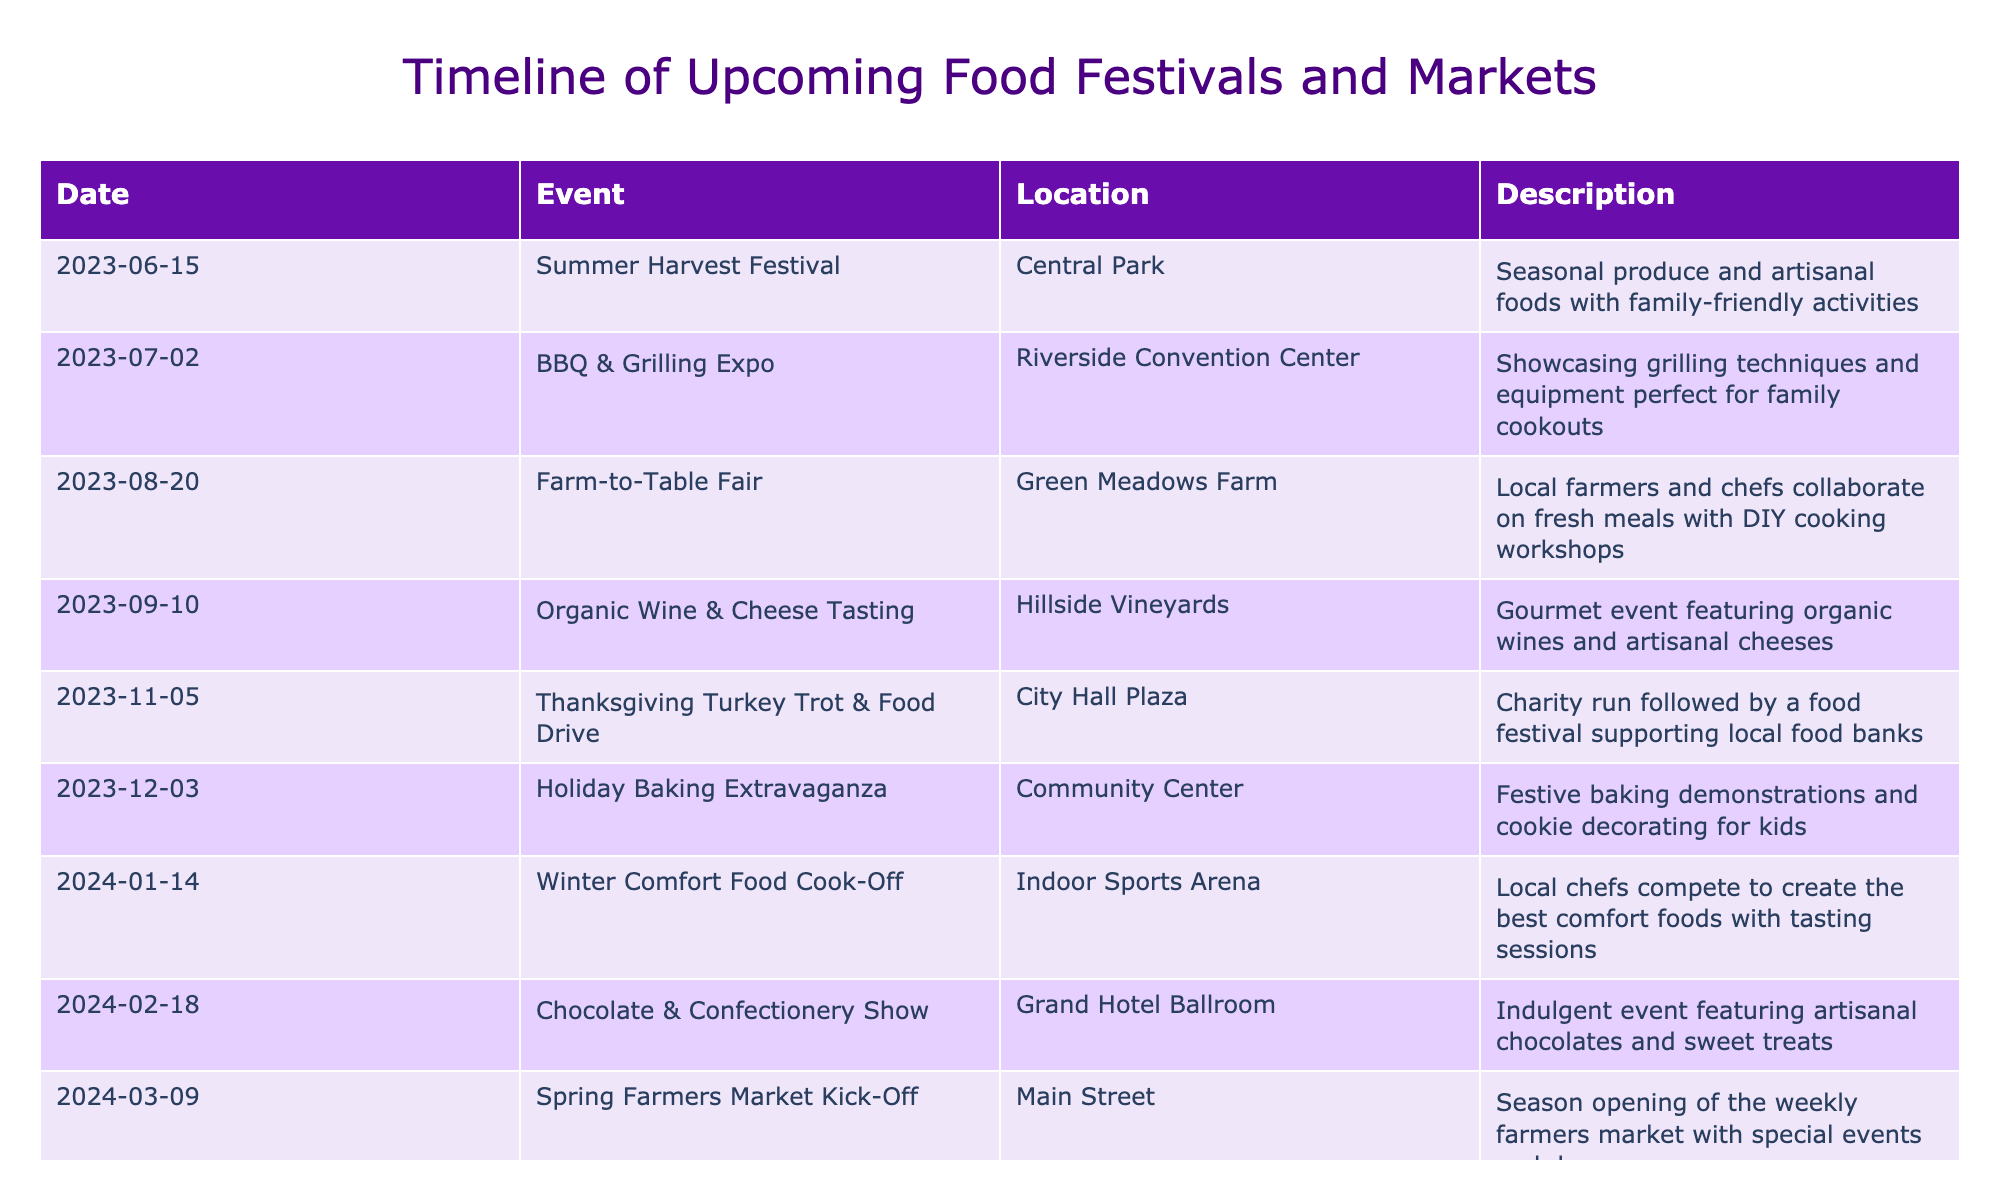What is the first event in the timeline? The first event in the timeline is determined by the earliest date listed. Scanning down the dates, the event on June 15, 2023, is the earliest.
Answer: Summer Harvest Festival How many events are scheduled in the month of August? There is one event listed in August. A quick glance at the table shows that the **Farm-to-Table Fair** is on August 20, 2023.
Answer: 1 Which location will host the Thanksgiving Turkey Trot & Food Drive? The table lists the location for this event. By checking the row for the Thanksgiving Turkey Trot & Food Drive, it is noted that it will take place at City Hall Plaza.
Answer: City Hall Plaza Is there an event focusing on chocolate before the summer months? This question requires checking the date of the Chocolate & Confectionery Show (February 18, 2024) and ensuring it occurs before June. Since February is before summer months (June), the answer is yes.
Answer: Yes What is the average time interval in days between the events in 2024? First, find the dates for all events occurring in 2024, then calculate the difference in days between consecutive events: January 14 to February 18 is 35 days, February 18 to March 9 is 19 days, March 9 to April 13 is 35 days, and April 13 to May 25 is 42 days. The total is 131 days. There are 4 intervals, so the average is 131 / 4 = 32.75 days.
Answer: 32.75 Which event is the last one in the list? Checking the table, the last event is the one with the latest date, which is listed as May 25, 2024: the International Street Food Festival.
Answer: International Street Food Festival Do all events in 2023 take place before the new year? To determine this, check all events listed with dates in 2023. Events range from June 15 to December 3, hence, all occur before January 1, 2024.
Answer: Yes What is the significance of the Earth Day Food & Sustainability Fair? The significance can be found in the description column for this event. It indicates a focus on eco-friendly food options and offers DIY gardening workshops, contributing to sustainability awareness.
Answer: Eco-friendly food and gardening workshops 